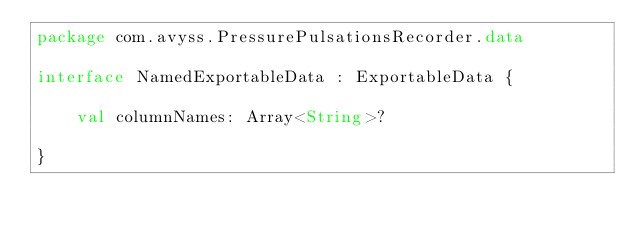Convert code to text. <code><loc_0><loc_0><loc_500><loc_500><_Kotlin_>package com.avyss.PressurePulsationsRecorder.data

interface NamedExportableData : ExportableData {

    val columnNames: Array<String>?

}
</code> 